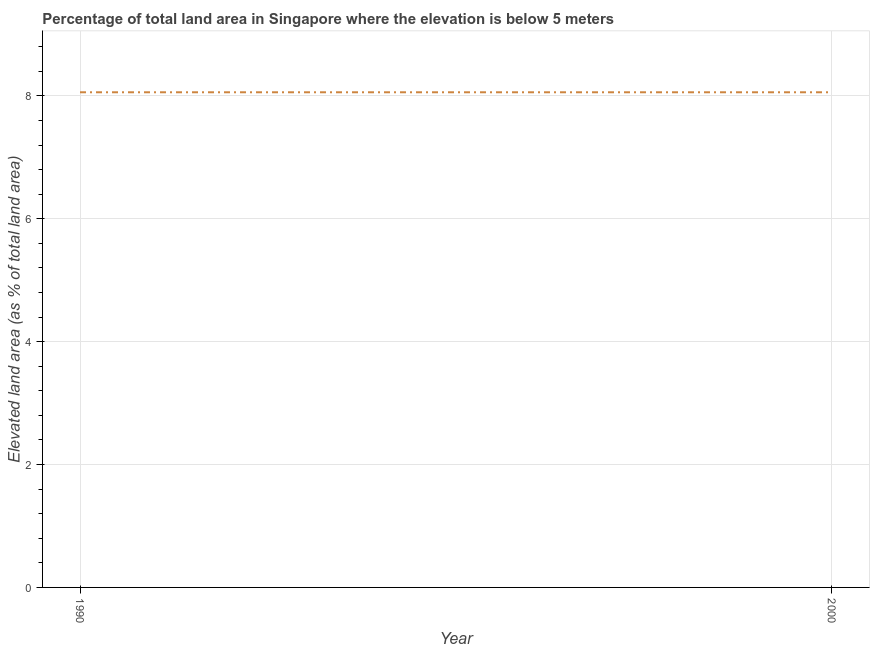What is the total elevated land area in 2000?
Provide a short and direct response. 8.06. Across all years, what is the maximum total elevated land area?
Your answer should be compact. 8.06. Across all years, what is the minimum total elevated land area?
Provide a succinct answer. 8.06. In which year was the total elevated land area maximum?
Keep it short and to the point. 1990. What is the sum of the total elevated land area?
Make the answer very short. 16.12. What is the difference between the total elevated land area in 1990 and 2000?
Your answer should be compact. 0. What is the average total elevated land area per year?
Provide a succinct answer. 8.06. What is the median total elevated land area?
Keep it short and to the point. 8.06. In how many years, is the total elevated land area greater than 2 %?
Offer a terse response. 2. What is the difference between two consecutive major ticks on the Y-axis?
Your answer should be compact. 2. Does the graph contain any zero values?
Your answer should be very brief. No. What is the title of the graph?
Offer a very short reply. Percentage of total land area in Singapore where the elevation is below 5 meters. What is the label or title of the X-axis?
Provide a succinct answer. Year. What is the label or title of the Y-axis?
Provide a succinct answer. Elevated land area (as % of total land area). What is the Elevated land area (as % of total land area) in 1990?
Offer a terse response. 8.06. What is the Elevated land area (as % of total land area) of 2000?
Provide a short and direct response. 8.06. 